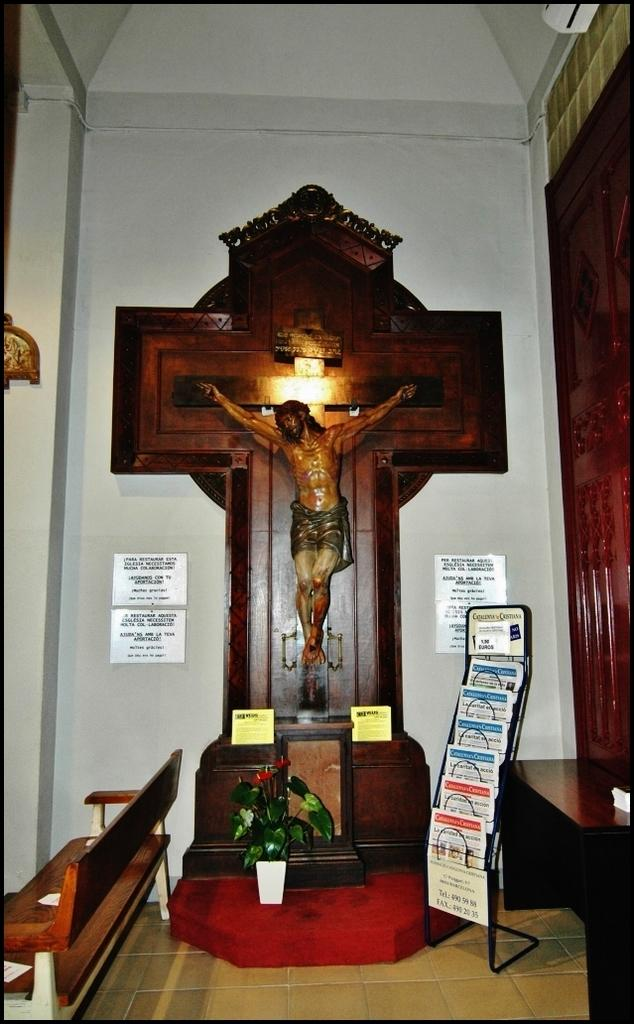What type of plant is visible in the image? There is a plant in the image, but the specific type cannot be determined from the facts provided. What type of furniture is present in the image? There is a bench and a table in the image. What items can be seen on the table in the image? There are books in a stand on the table in the image. What kind of artwork is featured in the image? There is a sculpture of a person in the image. What is attached to the wall in the image? There are boards fixed to the wall in the image. What statement is written on the lock in the image? There is no lock present in the image, so no statement can be read from it. What is the mass of the sculpture in the image? The mass of the sculpture cannot be determined from the image alone, as it depends on the material and size of the sculpture. 